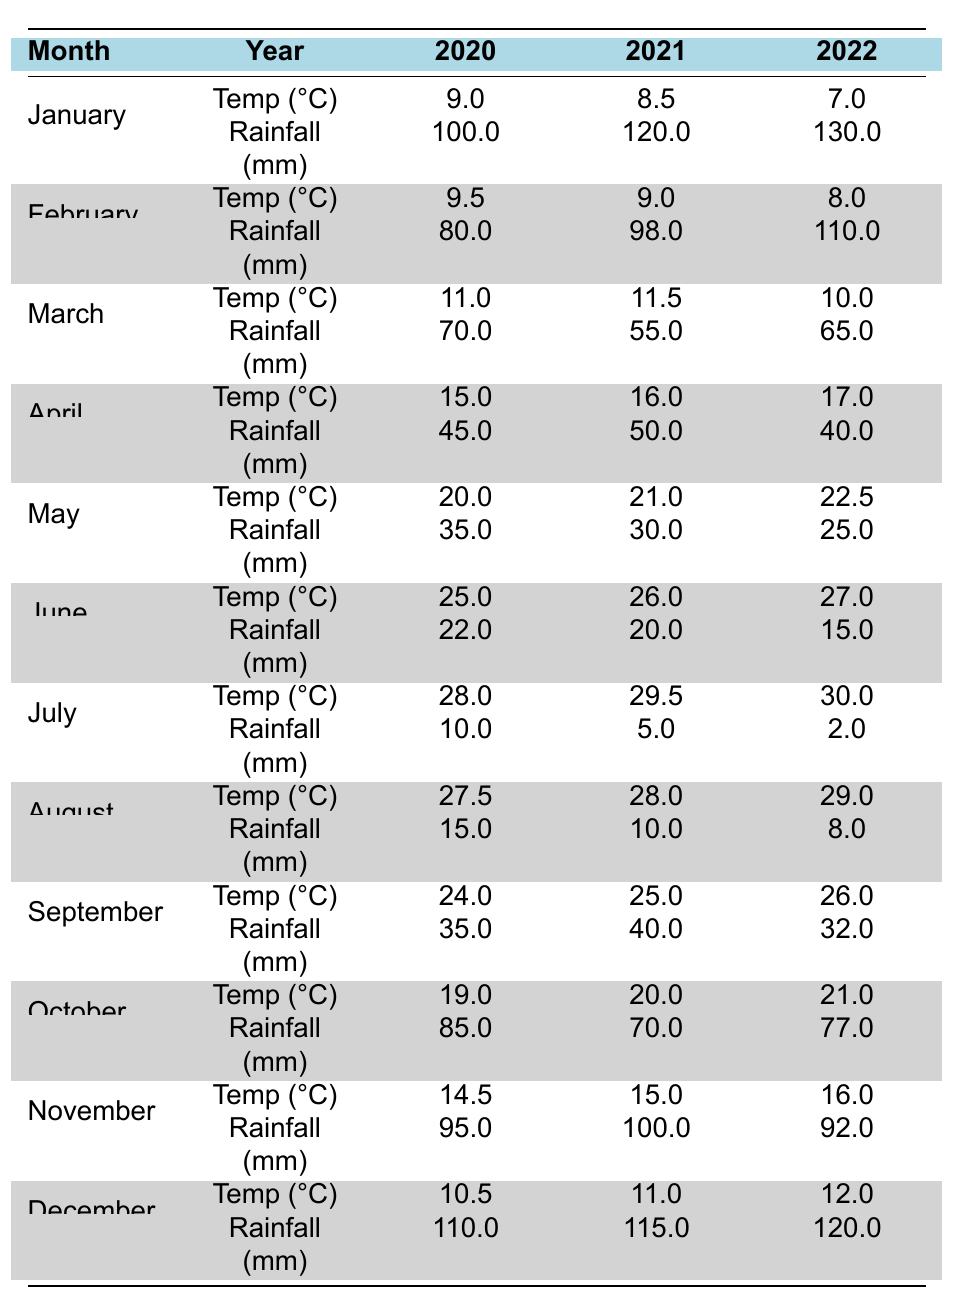What was the average temperature in Istanbul for July 2022? From the table, the average temperature for July 2022 is directly listed as 30.0°C.
Answer: 30.0°C How much rainfall did Istanbul receive on average in December across the three years? The rainfall values for December are 110.0 mm (2020), 115.0 mm (2021), and 120.0 mm (2022). The average is calculated as (110 + 115 + 120) / 3 = 115.0 mm.
Answer: 115.0 mm In which year did Istanbul experience the highest average temperature in May? The temperatures in May are 20.0°C (2020), 21.0°C (2021), and 22.5°C (2022). The highest is 22.5°C in 2022.
Answer: 2022 What is the total rainfall recorded in October for the years 2020, 2021, and 2022? The rainfall values for October are 85.0 mm (2020), 70.0 mm (2021), and 77.0 mm (2022). Adding these gives: 85 + 70 + 77 = 232.
Answer: 232.0 mm Did the average temperature in February 2021 exceed that of January 2021? The average temperatures are 9.0°C for February 2021 and 8.5°C for January 2021. Since 9.0°C is greater than 8.5°C, the statement is true.
Answer: Yes Which month had the least average rainfall in 2022? The average rainfall for all months in 2022 shows July has the least amount at 2.0 mm.
Answer: July What was the overall increase in average temperature from January 2020 to December 2022? The average temperature in January 2020 is 9.0°C and in December 2022 is 12.0°C. The increase is calculated as 12.0 - 9.0 = 3.0°C.
Answer: 3.0°C Which year had the highest average monthly rainfall? To find this, sum the rainfall for each year: 2020 = 100+80+70+45+35+22+10+15+35+85+95+110 = 725 mm; 2021 = 120+98+55+50+30+20+5+10+40+70+100+115 = 800 mm; 2022 = 130+110+65+40+25+15+2+8+32+77+92+120 = 822 mm. The highest is 822 mm in 2022.
Answer: 2022 Is the average temperature in June greater than that in October for any of the years listed? For 2020, 25.0°C (June) is greater than 19.0°C (October). For 2021, 26.0°C (June) is greater than 20.0°C (October). For 2022, 27.0°C (June) is greater than 21.0°C (October). Hence, the answer is yes for all three years.
Answer: Yes 